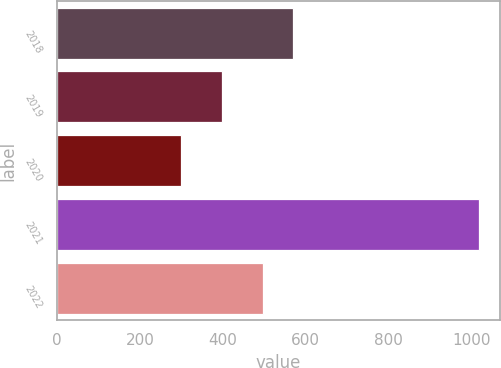<chart> <loc_0><loc_0><loc_500><loc_500><bar_chart><fcel>2018<fcel>2019<fcel>2020<fcel>2021<fcel>2022<nl><fcel>568.7<fcel>397<fcel>300<fcel>1017<fcel>497<nl></chart> 